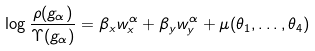<formula> <loc_0><loc_0><loc_500><loc_500>\log \frac { \rho ( g _ { \alpha } ) } { \Upsilon ( g _ { \alpha } ) } = \beta _ { x } w _ { x } ^ { \alpha } + \beta _ { y } w _ { y } ^ { \alpha } + \mu ( \theta _ { 1 } , \dots , \theta _ { 4 } )</formula> 